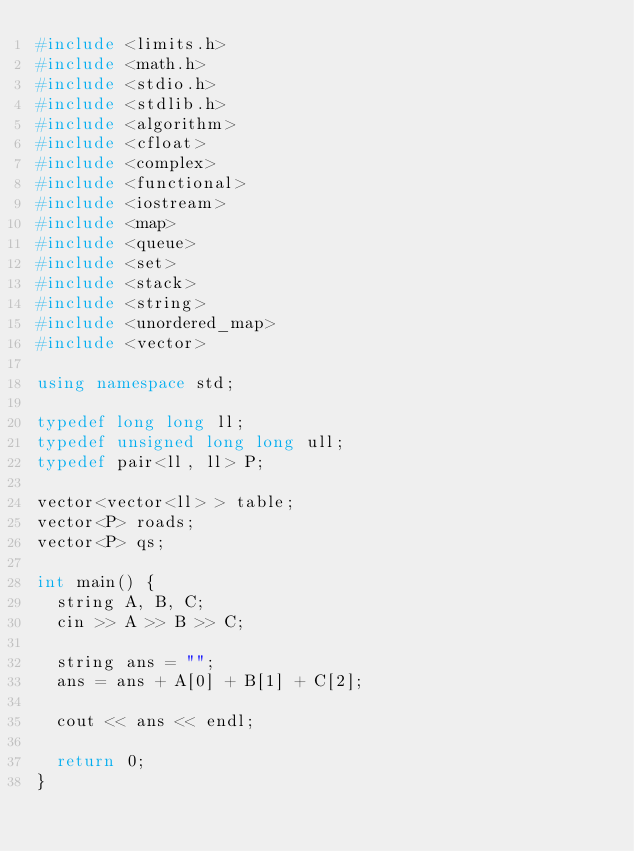Convert code to text. <code><loc_0><loc_0><loc_500><loc_500><_C++_>#include <limits.h>
#include <math.h>
#include <stdio.h>
#include <stdlib.h>
#include <algorithm>
#include <cfloat>
#include <complex>
#include <functional>
#include <iostream>
#include <map>
#include <queue>
#include <set>
#include <stack>
#include <string>
#include <unordered_map>
#include <vector>

using namespace std;

typedef long long ll;
typedef unsigned long long ull;
typedef pair<ll, ll> P;

vector<vector<ll> > table;
vector<P> roads;
vector<P> qs;

int main() {
  string A, B, C;
  cin >> A >> B >> C;

  string ans = "";
  ans = ans + A[0] + B[1] + C[2];

  cout << ans << endl;

  return 0;
}
</code> 